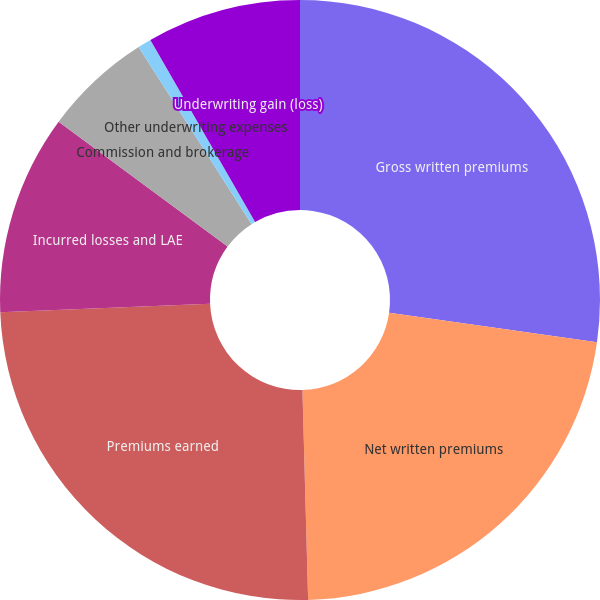Convert chart to OTSL. <chart><loc_0><loc_0><loc_500><loc_500><pie_chart><fcel>Gross written premiums<fcel>Net written premiums<fcel>Premiums earned<fcel>Incurred losses and LAE<fcel>Commission and brokerage<fcel>Other underwriting expenses<fcel>Underwriting gain (loss)<nl><fcel>27.25%<fcel>22.32%<fcel>24.78%<fcel>10.77%<fcel>5.84%<fcel>0.73%<fcel>8.31%<nl></chart> 